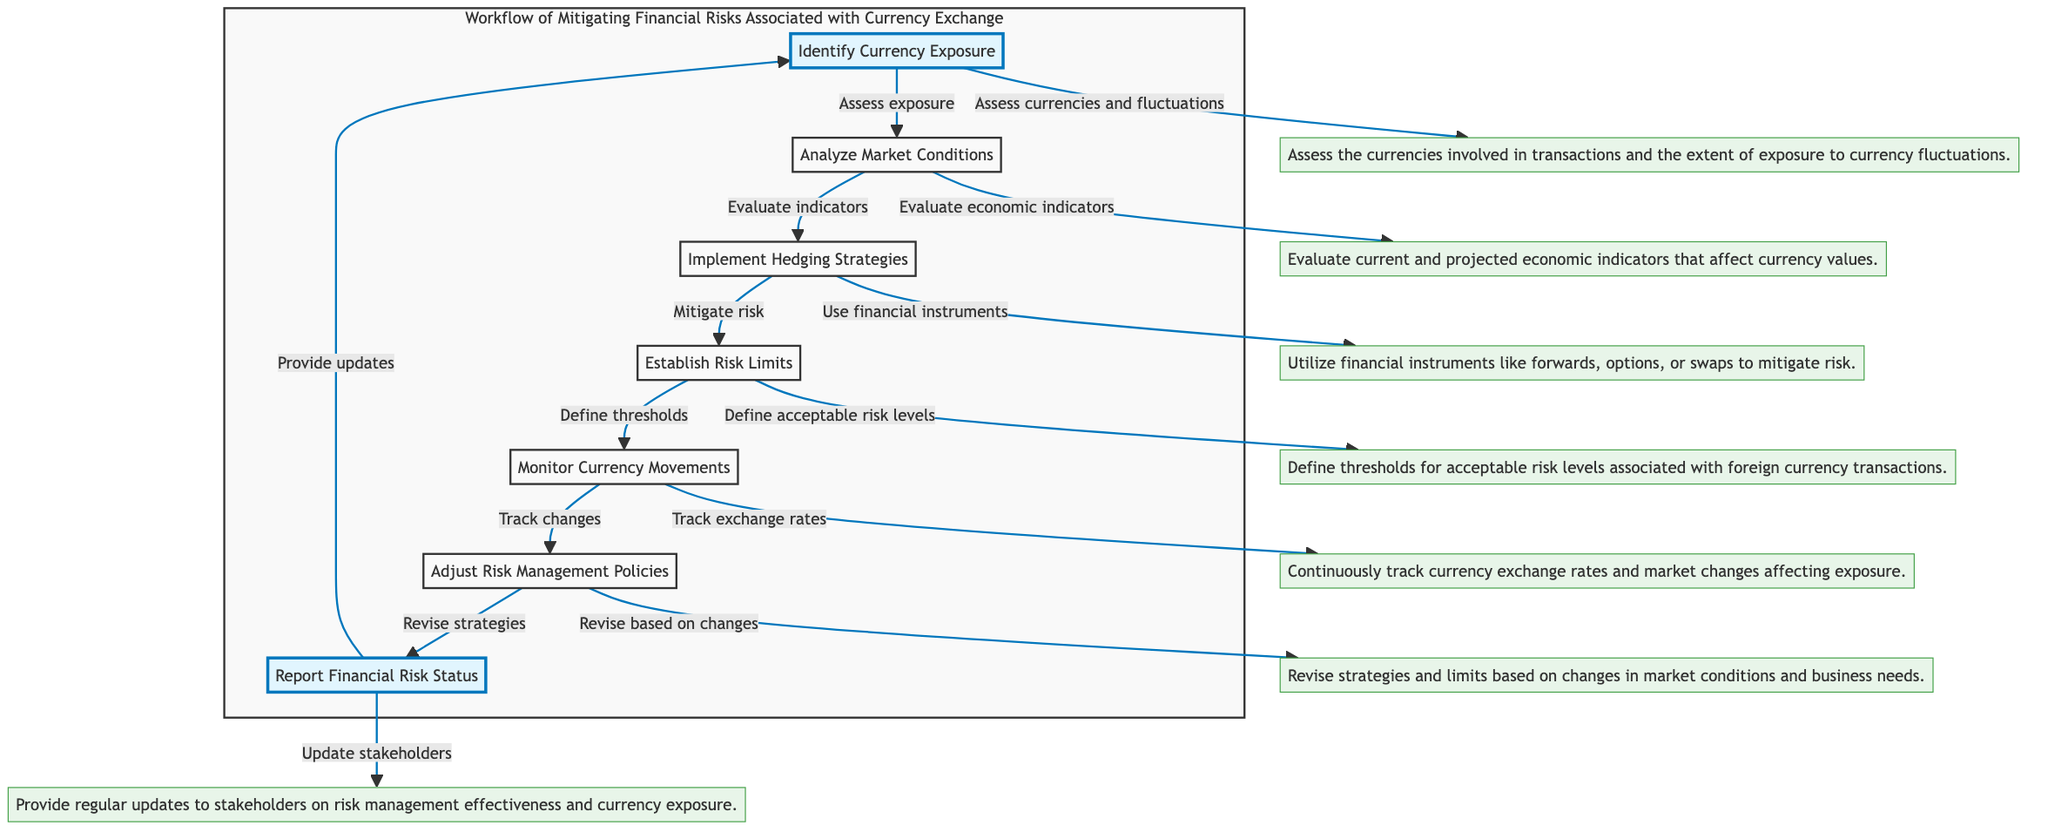What is the first step in the workflow? The first step in the workflow is represented by the node "Identify Currency Exposure," which signifies the initial action in assessing currency risks.
Answer: Identify Currency Exposure How many nodes are present in the diagram? The diagram includes a total of seven nodes that represent various steps in mitigating financial risks.
Answer: 7 What action follows "Analyze Market Conditions"? The action that follows "Analyze Market Conditions" is "Implement Hedging Strategies," indicating the transition in the workflow from analyzing to action.
Answer: Implement Hedging Strategies What is the last step mentioned in the workflow? The last step in the workflow is "Report Financial Risk Status," which indicates the conclusion of the risk management cycle.
Answer: Report Financial Risk Status Which node describes the revision of risk management strategies? The node that describes the revision of risk management strategies is "Adjust Risk Management Policies," which highlights the need for updating strategies based on market changes.
Answer: Adjust Risk Management Policies What is the relationship between "Monitor Currency Movements" and "Adjust Risk Management Policies"? "Monitor Currency Movements" precedes "Adjust Risk Management Policies," indicating that monitoring informs the adjustments made to risk management strategies.
Answer: Monitor Currency Movements → Adjust Risk Management Policies How are the nodes "Identify Currency Exposure" and "Report Financial Risk Status" highlighted in the diagram? Both "Identify Currency Exposure" and "Report Financial Risk Status" are highlighted, emphasizing their importance as key components in the risk management workflow.
Answer: Highlighted What provides stakeholders with updates on risk management effectiveness? The node "Report Financial Risk Status" is responsible for providing stakeholders with updates on the effectiveness of risk management regarding currency exposure.
Answer: Report Financial Risk Status What action is taken after defining thresholds for acceptable risk levels? After defining thresholds for acceptable risk levels, the action taken is to "Monitor Currency Movements," which continues the risk management process.
Answer: Monitor Currency Movements 